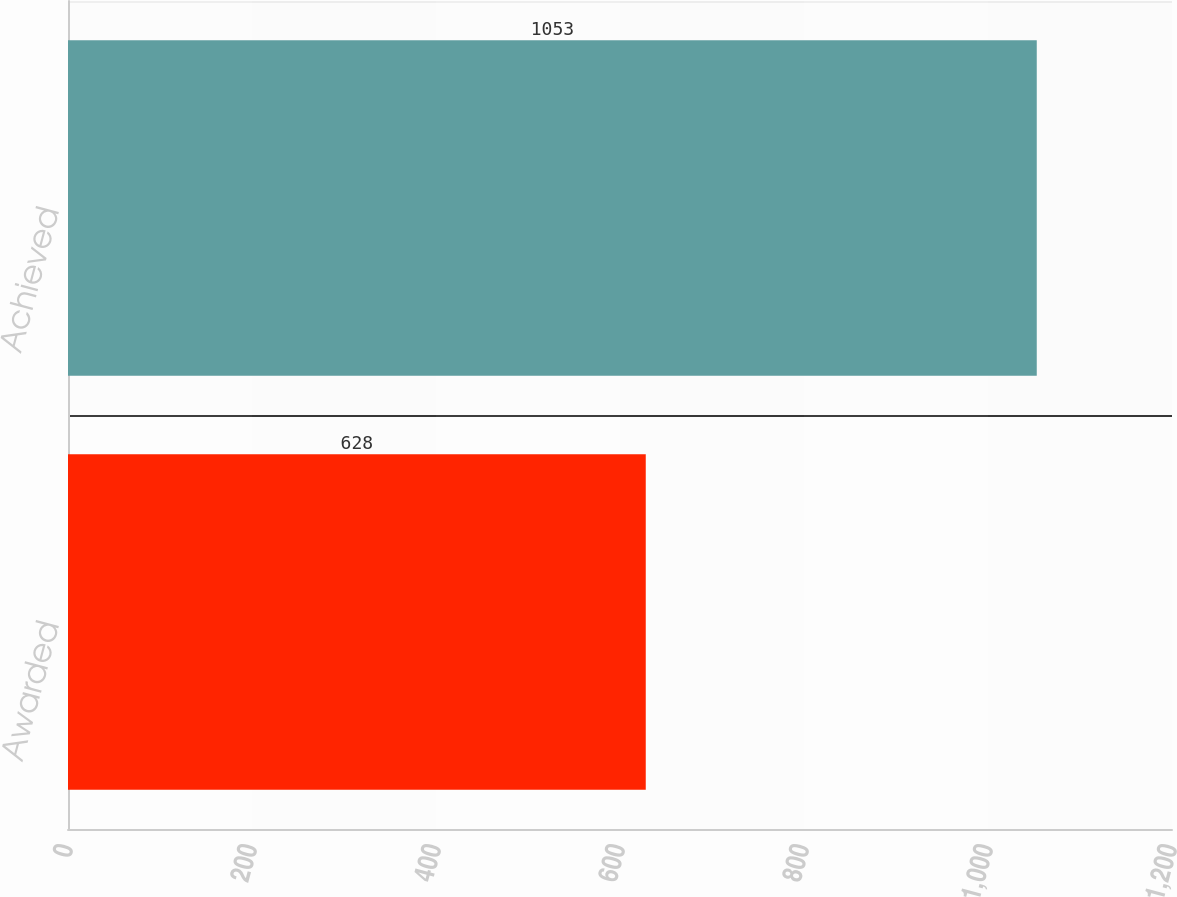Convert chart to OTSL. <chart><loc_0><loc_0><loc_500><loc_500><bar_chart><fcel>Awarded<fcel>Achieved<nl><fcel>628<fcel>1053<nl></chart> 